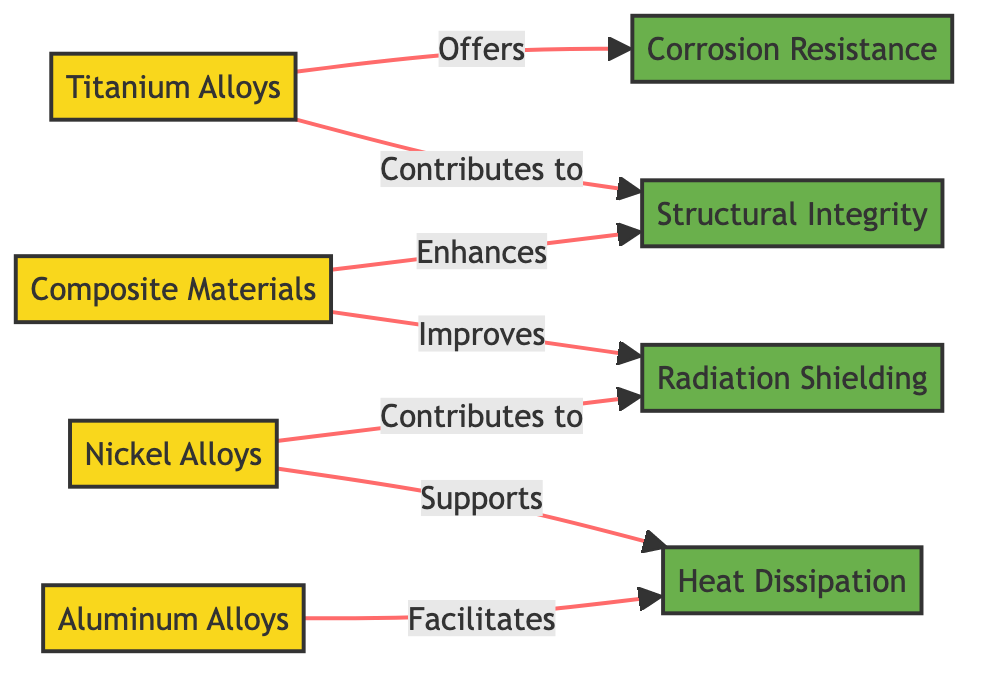What's the total number of alloy nodes in the diagram? The diagram includes four alloy nodes: Titanium Alloys, Nickel Alloys, Aluminum Alloys, and Composite Materials. Therefore, the count is four.
Answer: 4 Which property is enhanced by Composite Materials? The diagram indicates that Composite Materials enhance Structural Integrity as linked directly from Composite Materials to Structural Integrity.
Answer: Structural Integrity How many properties does Nickel Alloys contribute to? Nickel Alloys contributes to two properties: Heat Dissipation and Radiation Shielding, as evidenced from the two directed edges moving away from the Nickel Alloys node.
Answer: 2 What does Titanium Alloys offer? The diagram clearly shows a direct link stating that Titanium Alloys offers Corrosion Resistance, identified by the arrow pointing from Titanium Alloys to the Corrosion Resistance node.
Answer: Corrosion Resistance Which alloy facilitates Heat Dissipation? The diagram indicates that both Aluminum Alloys and Nickel Alloys facilitate Heat Dissipation, with the direct connection from Aluminum Alloys to Heat Dissipation and another from Nickel Alloys.
Answer: Aluminum Alloys and Nickel Alloys What relationship do Composite Materials have with Radiation Shielding? According to the diagram, Composite Materials improves Radiation Shielding, as indicated by the flow line connecting Composite Materials to the Radiation Shielding node.
Answer: Improves Which alloy contributes to Structural Integrity? The diagram shows that both Titanium Alloys and Composite Materials contribute to Structural Integrity, as shown by the arrows leading to the Structural Integrity node.
Answer: Titanium Alloys and Composite Materials Which properties does Aluminum Alloys support? The diagram illustrates that Aluminum Alloys support Heat Dissipation, with a direct link leading to that property from Aluminum Alloys.
Answer: Heat Dissipation How do Nickel Alloys and Titanium Alloys differ in their contributions to Radiation Shielding? Nickel Alloys contribute to Radiation Shielding, while Titanium Alloys also contribute to Radiation Shielding. The difference is not in contribution, but the properties they additionally support, where Nickel Alloys contribute to Heat Dissipation while Titanium Alloys do not.
Answer: Both contribute equally 